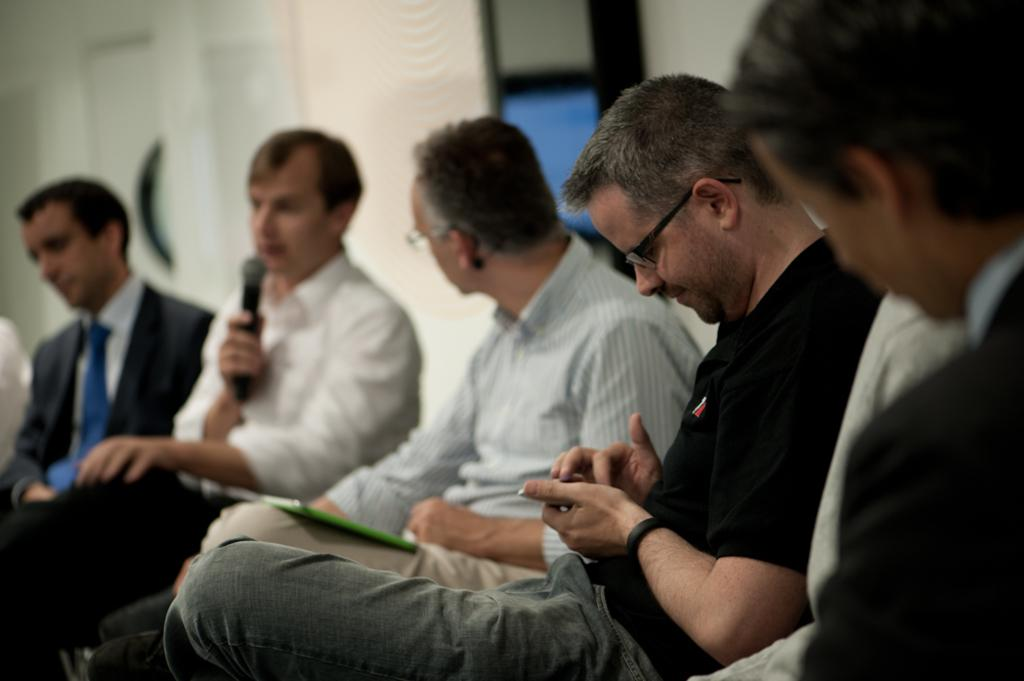What is the main subject of the image? The main subject of the image is a group of men. Can you describe what one of the men is doing? One man is holding a microphone in his hand. What can be observed about the background of the image? The background of the image is blurred. How many babies are present in the image, and are they wearing crowns? There are no babies present in the image, and therefore, they cannot be wearing crowns. 